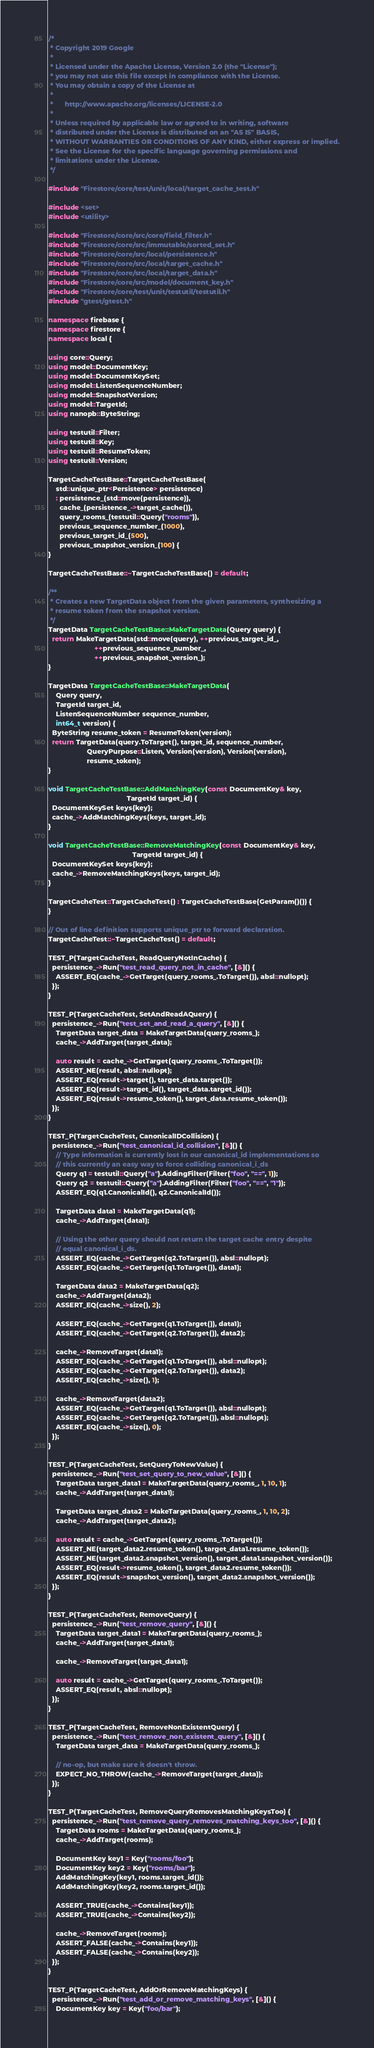<code> <loc_0><loc_0><loc_500><loc_500><_C++_>/*
 * Copyright 2019 Google
 *
 * Licensed under the Apache License, Version 2.0 (the "License");
 * you may not use this file except in compliance with the License.
 * You may obtain a copy of the License at
 *
 *      http://www.apache.org/licenses/LICENSE-2.0
 *
 * Unless required by applicable law or agreed to in writing, software
 * distributed under the License is distributed on an "AS IS" BASIS,
 * WITHOUT WARRANTIES OR CONDITIONS OF ANY KIND, either express or implied.
 * See the License for the specific language governing permissions and
 * limitations under the License.
 */

#include "Firestore/core/test/unit/local/target_cache_test.h"

#include <set>
#include <utility>

#include "Firestore/core/src/core/field_filter.h"
#include "Firestore/core/src/immutable/sorted_set.h"
#include "Firestore/core/src/local/persistence.h"
#include "Firestore/core/src/local/target_cache.h"
#include "Firestore/core/src/local/target_data.h"
#include "Firestore/core/src/model/document_key.h"
#include "Firestore/core/test/unit/testutil/testutil.h"
#include "gtest/gtest.h"

namespace firebase {
namespace firestore {
namespace local {

using core::Query;
using model::DocumentKey;
using model::DocumentKeySet;
using model::ListenSequenceNumber;
using model::SnapshotVersion;
using model::TargetId;
using nanopb::ByteString;

using testutil::Filter;
using testutil::Key;
using testutil::ResumeToken;
using testutil::Version;

TargetCacheTestBase::TargetCacheTestBase(
    std::unique_ptr<Persistence> persistence)
    : persistence_(std::move(persistence)),
      cache_(persistence_->target_cache()),
      query_rooms_(testutil::Query("rooms")),
      previous_sequence_number_(1000),
      previous_target_id_(500),
      previous_snapshot_version_(100) {
}

TargetCacheTestBase::~TargetCacheTestBase() = default;

/**
 * Creates a new TargetData object from the given parameters, synthesizing a
 * resume token from the snapshot version.
 */
TargetData TargetCacheTestBase::MakeTargetData(Query query) {
  return MakeTargetData(std::move(query), ++previous_target_id_,
                        ++previous_sequence_number_,
                        ++previous_snapshot_version_);
}

TargetData TargetCacheTestBase::MakeTargetData(
    Query query,
    TargetId target_id,
    ListenSequenceNumber sequence_number,
    int64_t version) {
  ByteString resume_token = ResumeToken(version);
  return TargetData(query.ToTarget(), target_id, sequence_number,
                    QueryPurpose::Listen, Version(version), Version(version),
                    resume_token);
}

void TargetCacheTestBase::AddMatchingKey(const DocumentKey& key,
                                         TargetId target_id) {
  DocumentKeySet keys{key};
  cache_->AddMatchingKeys(keys, target_id);
}

void TargetCacheTestBase::RemoveMatchingKey(const DocumentKey& key,
                                            TargetId target_id) {
  DocumentKeySet keys{key};
  cache_->RemoveMatchingKeys(keys, target_id);
}

TargetCacheTest::TargetCacheTest() : TargetCacheTestBase(GetParam()()) {
}

// Out of line definition supports unique_ptr to forward declaration.
TargetCacheTest::~TargetCacheTest() = default;

TEST_P(TargetCacheTest, ReadQueryNotInCache) {
  persistence_->Run("test_read_query_not_in_cache", [&]() {
    ASSERT_EQ(cache_->GetTarget(query_rooms_.ToTarget()), absl::nullopt);
  });
}

TEST_P(TargetCacheTest, SetAndReadAQuery) {
  persistence_->Run("test_set_and_read_a_query", [&]() {
    TargetData target_data = MakeTargetData(query_rooms_);
    cache_->AddTarget(target_data);

    auto result = cache_->GetTarget(query_rooms_.ToTarget());
    ASSERT_NE(result, absl::nullopt);
    ASSERT_EQ(result->target(), target_data.target());
    ASSERT_EQ(result->target_id(), target_data.target_id());
    ASSERT_EQ(result->resume_token(), target_data.resume_token());
  });
}

TEST_P(TargetCacheTest, CanonicalIDCollision) {
  persistence_->Run("test_canonical_id_collision", [&]() {
    // Type information is currently lost in our canonical_id implementations so
    // this currently an easy way to force colliding canonical_i_ds
    Query q1 = testutil::Query("a").AddingFilter(Filter("foo", "==", 1));
    Query q2 = testutil::Query("a").AddingFilter(Filter("foo", "==", "1"));
    ASSERT_EQ(q1.CanonicalId(), q2.CanonicalId());

    TargetData data1 = MakeTargetData(q1);
    cache_->AddTarget(data1);

    // Using the other query should not return the target cache entry despite
    // equal canonical_i_ds.
    ASSERT_EQ(cache_->GetTarget(q2.ToTarget()), absl::nullopt);
    ASSERT_EQ(cache_->GetTarget(q1.ToTarget()), data1);

    TargetData data2 = MakeTargetData(q2);
    cache_->AddTarget(data2);
    ASSERT_EQ(cache_->size(), 2);

    ASSERT_EQ(cache_->GetTarget(q1.ToTarget()), data1);
    ASSERT_EQ(cache_->GetTarget(q2.ToTarget()), data2);

    cache_->RemoveTarget(data1);
    ASSERT_EQ(cache_->GetTarget(q1.ToTarget()), absl::nullopt);
    ASSERT_EQ(cache_->GetTarget(q2.ToTarget()), data2);
    ASSERT_EQ(cache_->size(), 1);

    cache_->RemoveTarget(data2);
    ASSERT_EQ(cache_->GetTarget(q1.ToTarget()), absl::nullopt);
    ASSERT_EQ(cache_->GetTarget(q2.ToTarget()), absl::nullopt);
    ASSERT_EQ(cache_->size(), 0);
  });
}

TEST_P(TargetCacheTest, SetQueryToNewValue) {
  persistence_->Run("test_set_query_to_new_value", [&]() {
    TargetData target_data1 = MakeTargetData(query_rooms_, 1, 10, 1);
    cache_->AddTarget(target_data1);

    TargetData target_data2 = MakeTargetData(query_rooms_, 1, 10, 2);
    cache_->AddTarget(target_data2);

    auto result = cache_->GetTarget(query_rooms_.ToTarget());
    ASSERT_NE(target_data2.resume_token(), target_data1.resume_token());
    ASSERT_NE(target_data2.snapshot_version(), target_data1.snapshot_version());
    ASSERT_EQ(result->resume_token(), target_data2.resume_token());
    ASSERT_EQ(result->snapshot_version(), target_data2.snapshot_version());
  });
}

TEST_P(TargetCacheTest, RemoveQuery) {
  persistence_->Run("test_remove_query", [&]() {
    TargetData target_data1 = MakeTargetData(query_rooms_);
    cache_->AddTarget(target_data1);

    cache_->RemoveTarget(target_data1);

    auto result = cache_->GetTarget(query_rooms_.ToTarget());
    ASSERT_EQ(result, absl::nullopt);
  });
}

TEST_P(TargetCacheTest, RemoveNonExistentQuery) {
  persistence_->Run("test_remove_non_existent_query", [&]() {
    TargetData target_data = MakeTargetData(query_rooms_);

    // no-op, but make sure it doesn't throw.
    EXPECT_NO_THROW(cache_->RemoveTarget(target_data));
  });
}

TEST_P(TargetCacheTest, RemoveQueryRemovesMatchingKeysToo) {
  persistence_->Run("test_remove_query_removes_matching_keys_too", [&]() {
    TargetData rooms = MakeTargetData(query_rooms_);
    cache_->AddTarget(rooms);

    DocumentKey key1 = Key("rooms/foo");
    DocumentKey key2 = Key("rooms/bar");
    AddMatchingKey(key1, rooms.target_id());
    AddMatchingKey(key2, rooms.target_id());

    ASSERT_TRUE(cache_->Contains(key1));
    ASSERT_TRUE(cache_->Contains(key2));

    cache_->RemoveTarget(rooms);
    ASSERT_FALSE(cache_->Contains(key1));
    ASSERT_FALSE(cache_->Contains(key2));
  });
}

TEST_P(TargetCacheTest, AddOrRemoveMatchingKeys) {
  persistence_->Run("test_add_or_remove_matching_keys", [&]() {
    DocumentKey key = Key("foo/bar");
</code> 